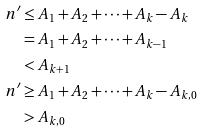<formula> <loc_0><loc_0><loc_500><loc_500>n ^ { \prime } & \leq A _ { 1 } + A _ { 2 } + \cdots + A _ { k } - A _ { k } \\ & = A _ { 1 } + A _ { 2 } + \cdots + A _ { k - 1 } \\ & < A _ { k + 1 } \\ n ^ { \prime } & \geq A _ { 1 } + A _ { 2 } + \cdots + A _ { k } - A _ { k , 0 } \\ & > A _ { k , 0 } \\</formula> 